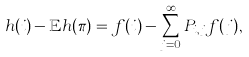Convert formula to latex. <formula><loc_0><loc_0><loc_500><loc_500>h ( i ) - \mathbb { E } h ( \pi ) = f ( i ) - \sum _ { j = 0 } ^ { \infty } P _ { i , j } f ( j ) ,</formula> 